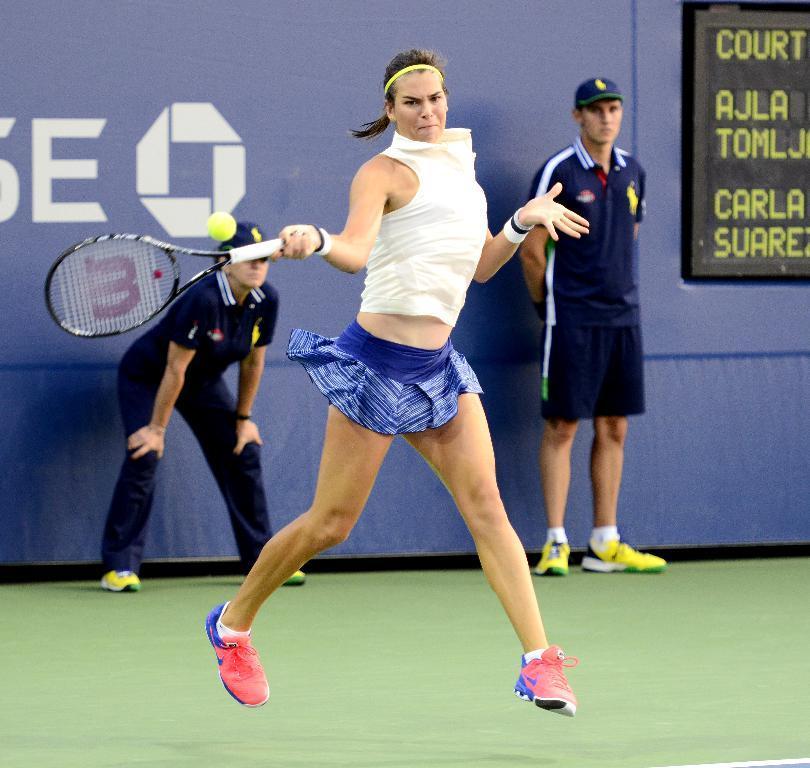Describe this image in one or two sentences. In the image we can see there is a woman who is standing and holding tennis racket in her hand and she is hitting a ball and behind there are people who are standing and they are watching the woman. 